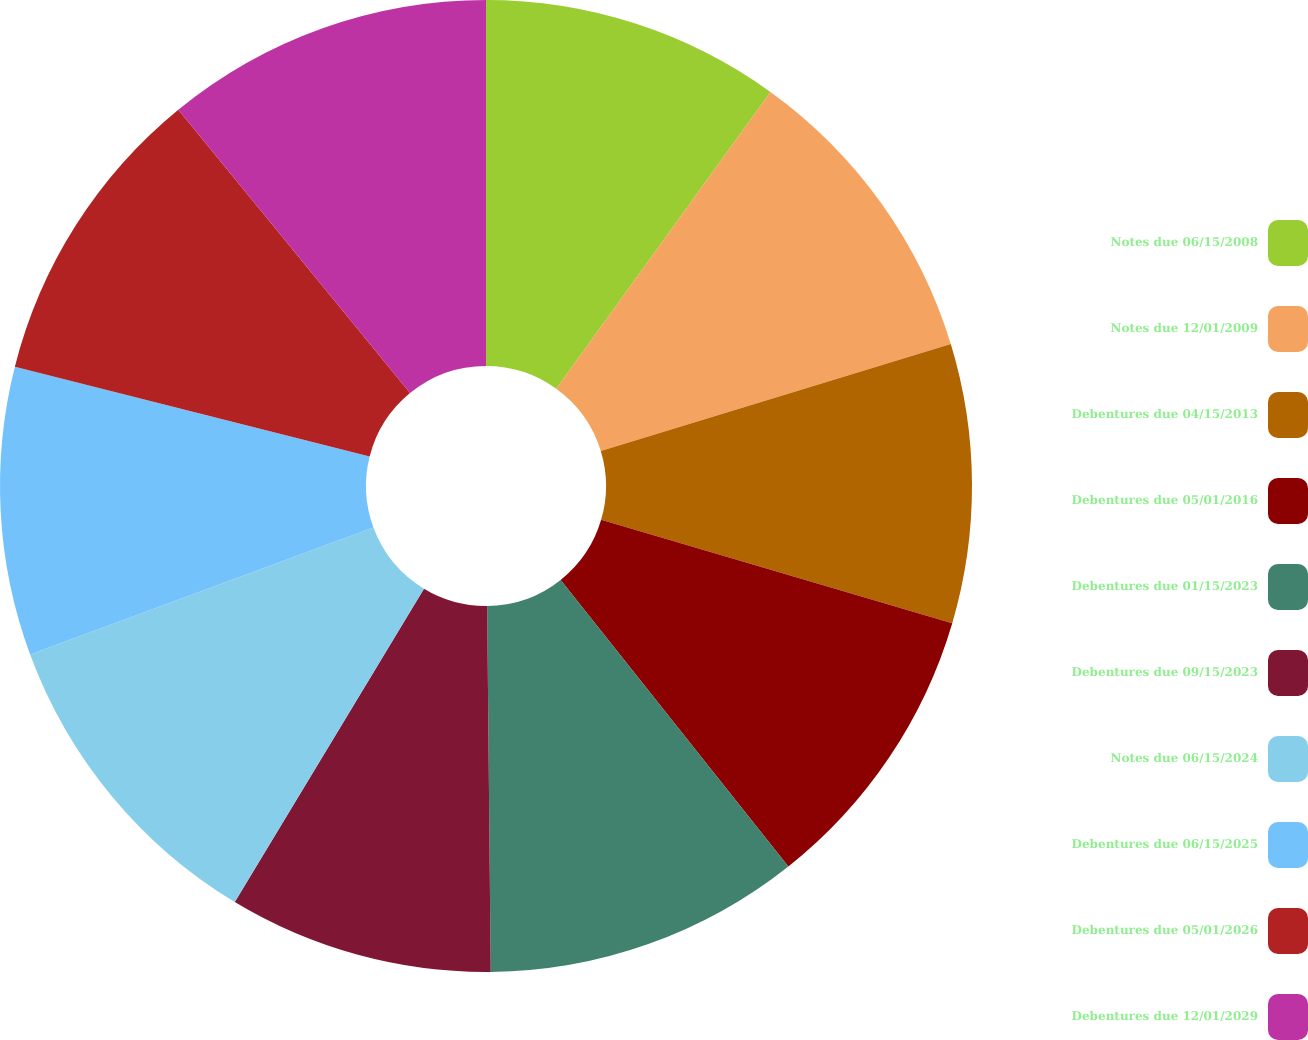<chart> <loc_0><loc_0><loc_500><loc_500><pie_chart><fcel>Notes due 06/15/2008<fcel>Notes due 12/01/2009<fcel>Debentures due 04/15/2013<fcel>Debentures due 05/01/2016<fcel>Debentures due 01/15/2023<fcel>Debentures due 09/15/2023<fcel>Notes due 06/15/2024<fcel>Debentures due 06/15/2025<fcel>Debentures due 05/01/2026<fcel>Debentures due 12/01/2029<nl><fcel>9.95%<fcel>10.33%<fcel>9.27%<fcel>9.76%<fcel>10.53%<fcel>8.8%<fcel>10.72%<fcel>9.58%<fcel>10.14%<fcel>10.91%<nl></chart> 